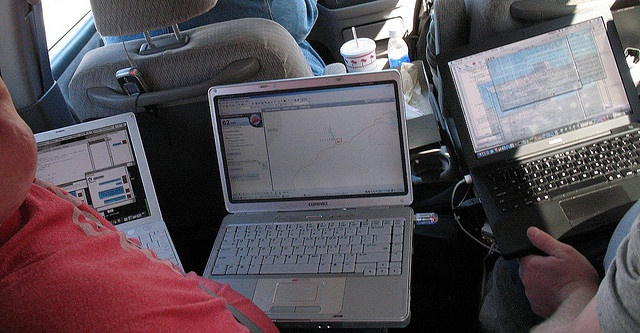Describe the objects in this image and their specific colors. I can see laptop in gray and black tones, laptop in gray, black, darkgray, and lightgray tones, people in gray, maroon, and brown tones, people in gray, black, and maroon tones, and laptop in gray and black tones in this image. 